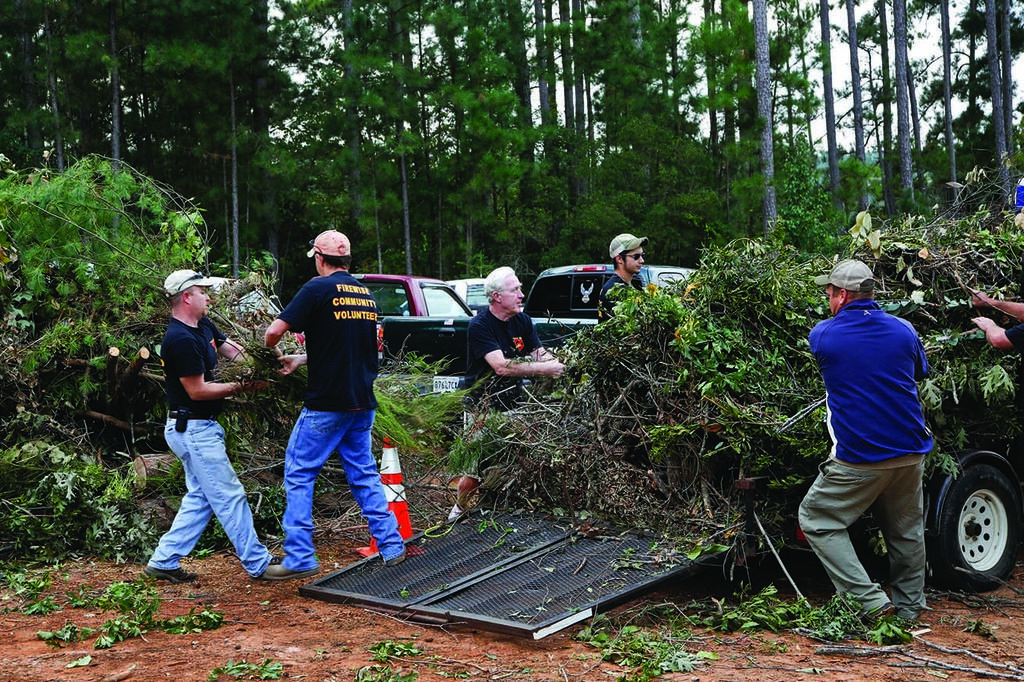Who or what is present in the image? There are people and trucks in the image. What are the people doing in the image? The people are putting cut trees on a truck. Can you describe the trucks in the image? There are trucks in the image, but no specific details about their appearance or type are provided. What can be seen in the background of the image? There are trees in the background of the image. How many attempts does the flock of birds make to fly through the nerve of the tree in the image? There are no birds or nerves present in the image; it features people putting cut trees on a truck with trees in the background. 